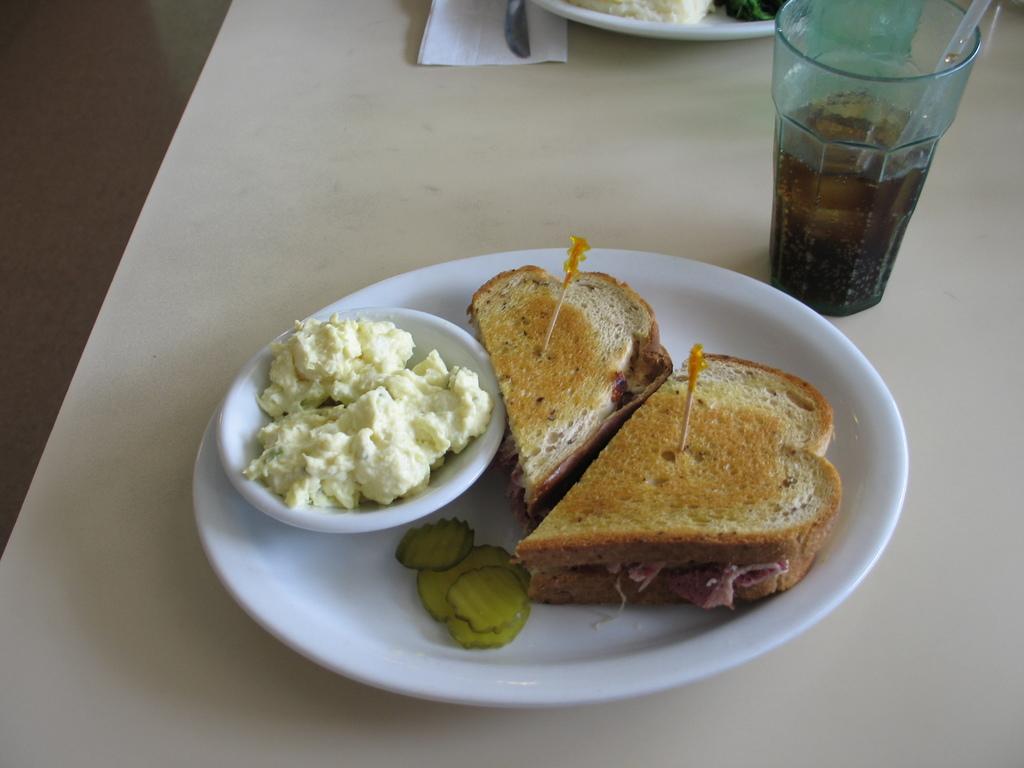Please provide a concise description of this image. In this picture I can see the food items and a bowl in a plate. On the right side I can see a glass on the table, at the top there is a knife, plate and a tissue paper. 